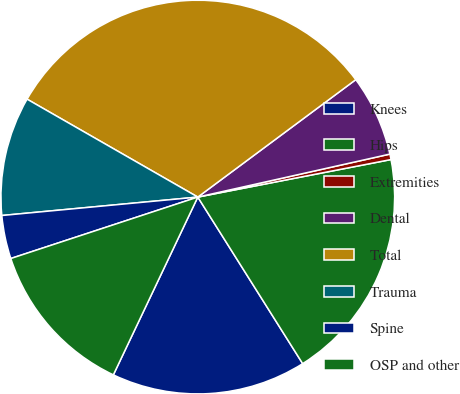Convert chart to OTSL. <chart><loc_0><loc_0><loc_500><loc_500><pie_chart><fcel>Knees<fcel>Hips<fcel>Extremities<fcel>Dental<fcel>Total<fcel>Trauma<fcel>Spine<fcel>OSP and other<nl><fcel>16.0%<fcel>19.11%<fcel>0.45%<fcel>6.67%<fcel>31.54%<fcel>9.78%<fcel>3.56%<fcel>12.89%<nl></chart> 